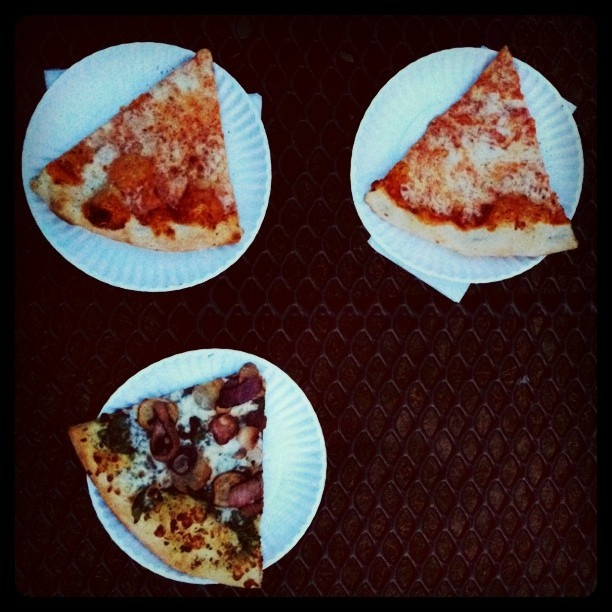Describe the objects in this image and their specific colors. I can see pizza in black, maroon, tan, and darkgray tones, pizza in black, maroon, and brown tones, and pizza in black, darkgray, brown, maroon, and tan tones in this image. 